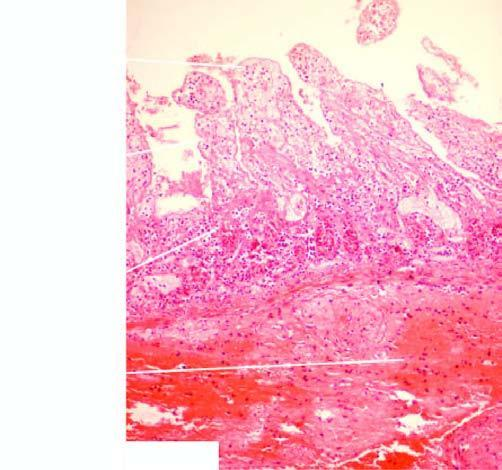where is inflammatory cell infiltration marked at?
Answer the question using a single word or phrase. Line of demarcation between the infarcted and normal bowel 